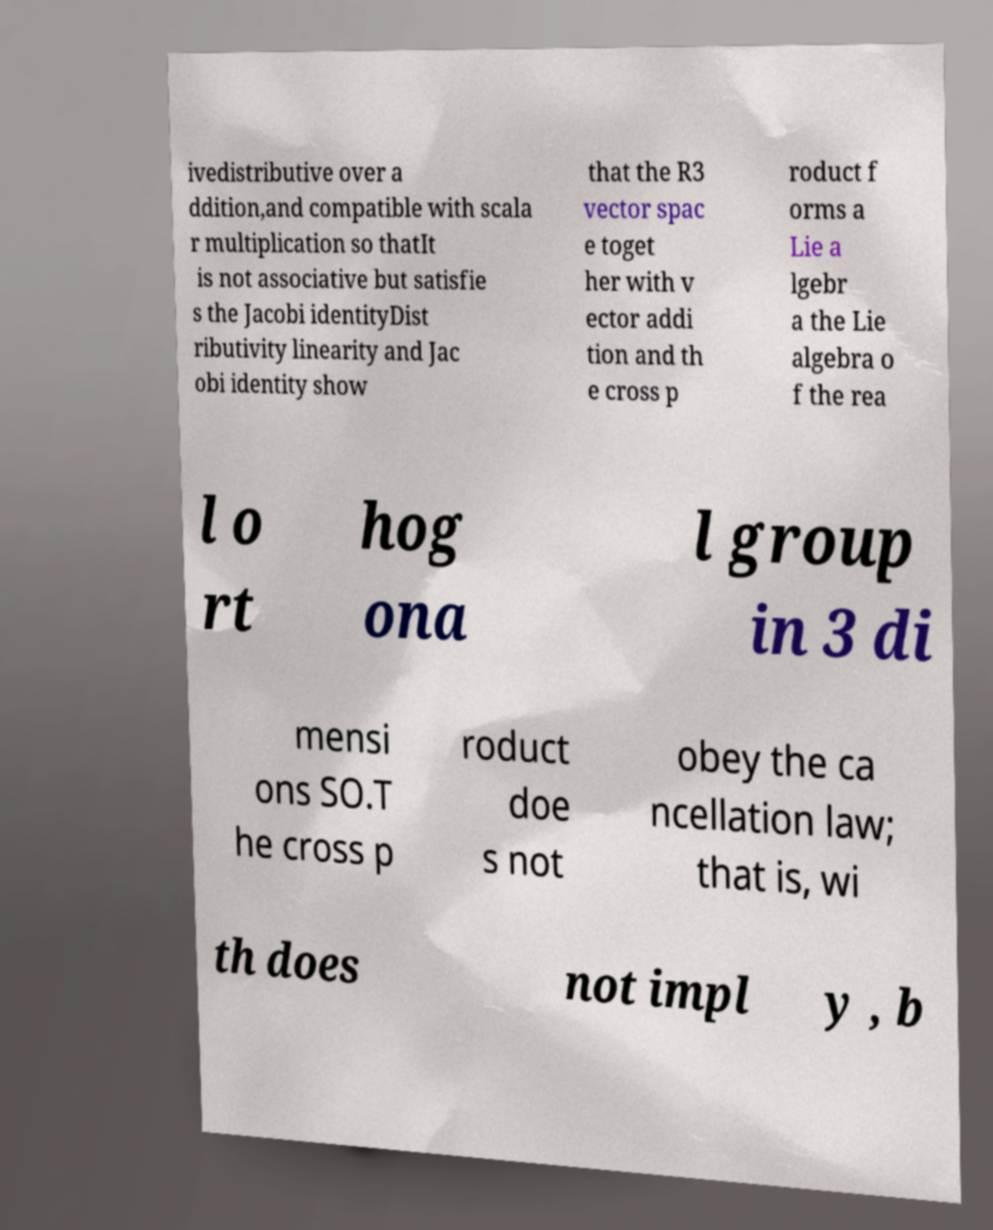For documentation purposes, I need the text within this image transcribed. Could you provide that? ivedistributive over a ddition,and compatible with scala r multiplication so thatIt is not associative but satisfie s the Jacobi identityDist ributivity linearity and Jac obi identity show that the R3 vector spac e toget her with v ector addi tion and th e cross p roduct f orms a Lie a lgebr a the Lie algebra o f the rea l o rt hog ona l group in 3 di mensi ons SO.T he cross p roduct doe s not obey the ca ncellation law; that is, wi th does not impl y , b 